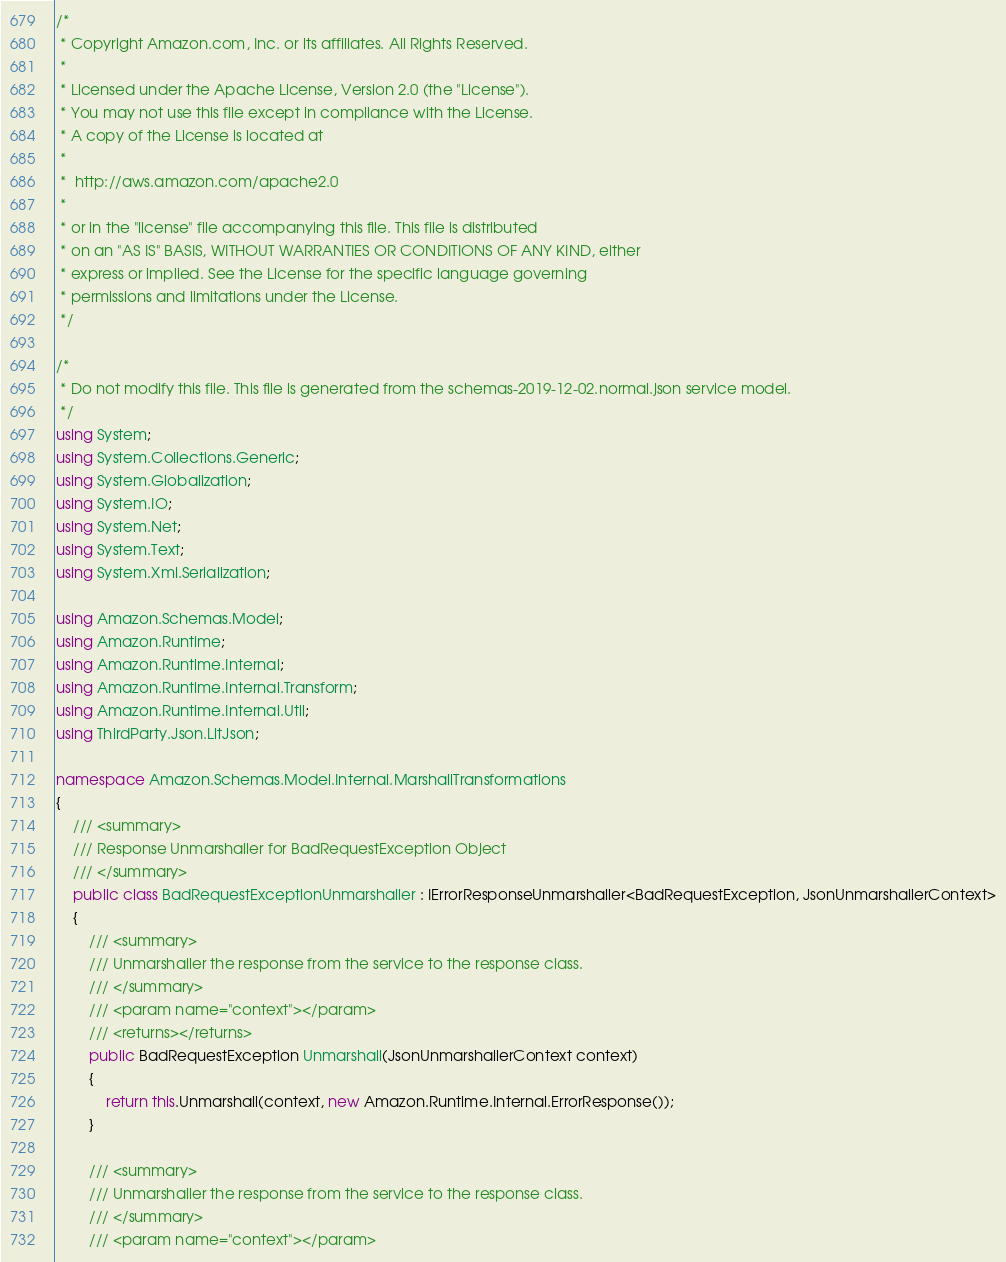<code> <loc_0><loc_0><loc_500><loc_500><_C#_>/*
 * Copyright Amazon.com, Inc. or its affiliates. All Rights Reserved.
 * 
 * Licensed under the Apache License, Version 2.0 (the "License").
 * You may not use this file except in compliance with the License.
 * A copy of the License is located at
 * 
 *  http://aws.amazon.com/apache2.0
 * 
 * or in the "license" file accompanying this file. This file is distributed
 * on an "AS IS" BASIS, WITHOUT WARRANTIES OR CONDITIONS OF ANY KIND, either
 * express or implied. See the License for the specific language governing
 * permissions and limitations under the License.
 */

/*
 * Do not modify this file. This file is generated from the schemas-2019-12-02.normal.json service model.
 */
using System;
using System.Collections.Generic;
using System.Globalization;
using System.IO;
using System.Net;
using System.Text;
using System.Xml.Serialization;

using Amazon.Schemas.Model;
using Amazon.Runtime;
using Amazon.Runtime.Internal;
using Amazon.Runtime.Internal.Transform;
using Amazon.Runtime.Internal.Util;
using ThirdParty.Json.LitJson;

namespace Amazon.Schemas.Model.Internal.MarshallTransformations
{
    /// <summary>
    /// Response Unmarshaller for BadRequestException Object
    /// </summary>  
    public class BadRequestExceptionUnmarshaller : IErrorResponseUnmarshaller<BadRequestException, JsonUnmarshallerContext>
    {
        /// <summary>
        /// Unmarshaller the response from the service to the response class.
        /// </summary>  
        /// <param name="context"></param>
        /// <returns></returns>
        public BadRequestException Unmarshall(JsonUnmarshallerContext context)
        {
            return this.Unmarshall(context, new Amazon.Runtime.Internal.ErrorResponse());
        }

        /// <summary>
        /// Unmarshaller the response from the service to the response class.
        /// </summary>  
        /// <param name="context"></param></code> 